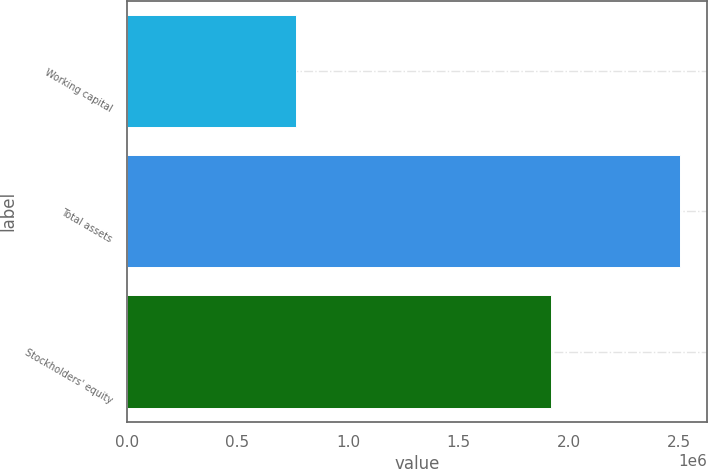<chart> <loc_0><loc_0><loc_500><loc_500><bar_chart><fcel>Working capital<fcel>Total assets<fcel>Stockholders' equity<nl><fcel>766418<fcel>2.5022e+06<fcel>1.91832e+06<nl></chart> 